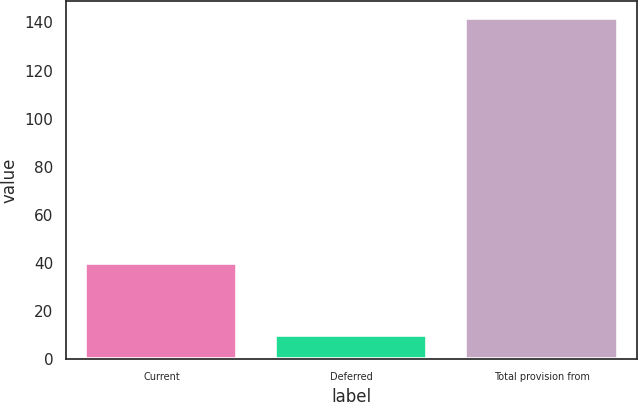Convert chart. <chart><loc_0><loc_0><loc_500><loc_500><bar_chart><fcel>Current<fcel>Deferred<fcel>Total provision from<nl><fcel>40<fcel>10<fcel>142<nl></chart> 